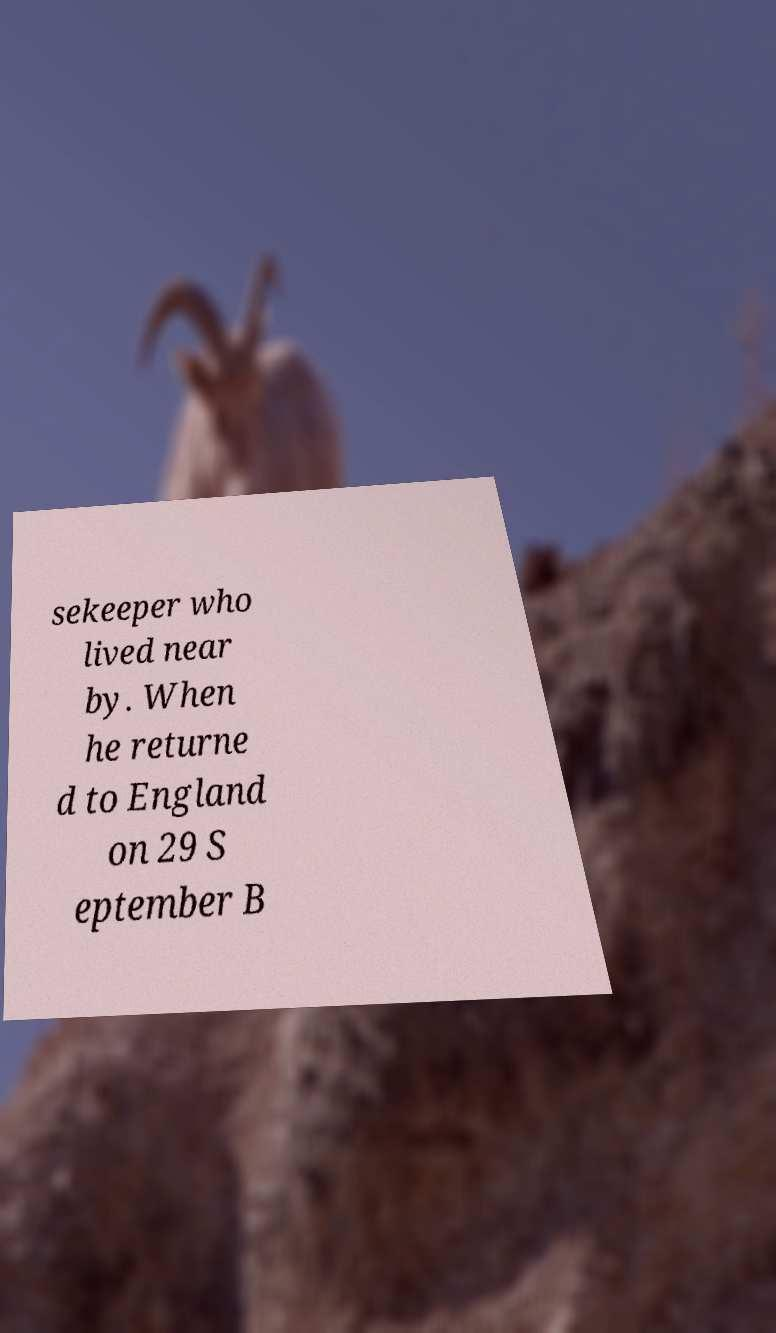Can you accurately transcribe the text from the provided image for me? sekeeper who lived near by. When he returne d to England on 29 S eptember B 